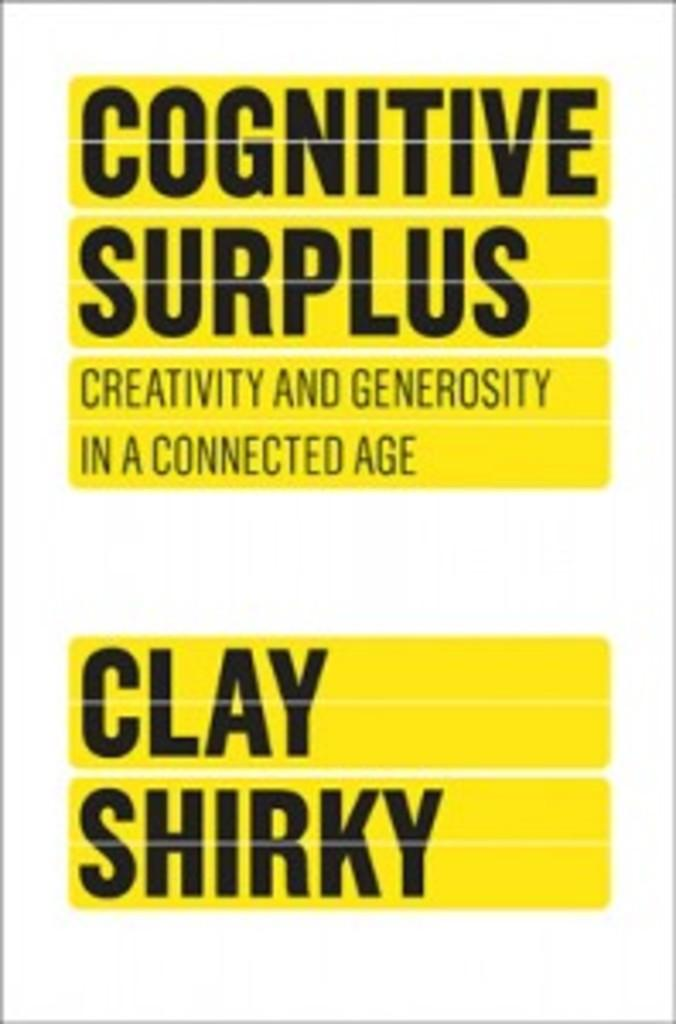Provide a one-sentence caption for the provided image. A book by Clay Shirky entitled "Cognitive Surplus; Creativity and generosity in a connected age". 